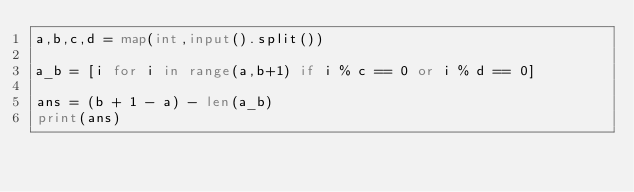<code> <loc_0><loc_0><loc_500><loc_500><_Python_>a,b,c,d = map(int,input().split())

a_b = [i for i in range(a,b+1) if i % c == 0 or i % d == 0]

ans = (b + 1 - a) - len(a_b)
print(ans)</code> 